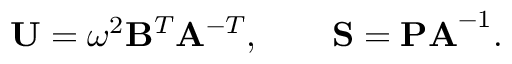<formula> <loc_0><loc_0><loc_500><loc_500>U = \omega ^ { 2 } B ^ { T } A ^ { - T } , \quad S = P A ^ { - 1 } .</formula> 